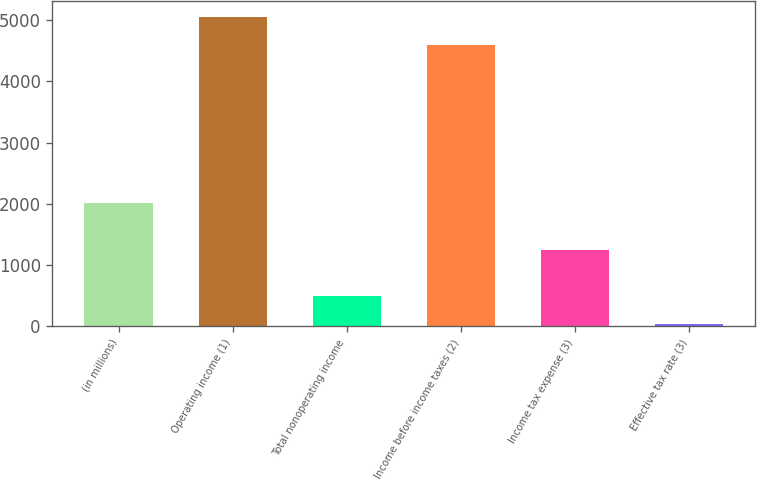Convert chart. <chart><loc_0><loc_0><loc_500><loc_500><bar_chart><fcel>(in millions)<fcel>Operating income (1)<fcel>Total nonoperating income<fcel>Income before income taxes (2)<fcel>Income tax expense (3)<fcel>Effective tax rate (3)<nl><fcel>2015<fcel>5058.68<fcel>490.88<fcel>4595<fcel>1250<fcel>27.2<nl></chart> 